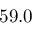<formula> <loc_0><loc_0><loc_500><loc_500>5 9 . 0</formula> 